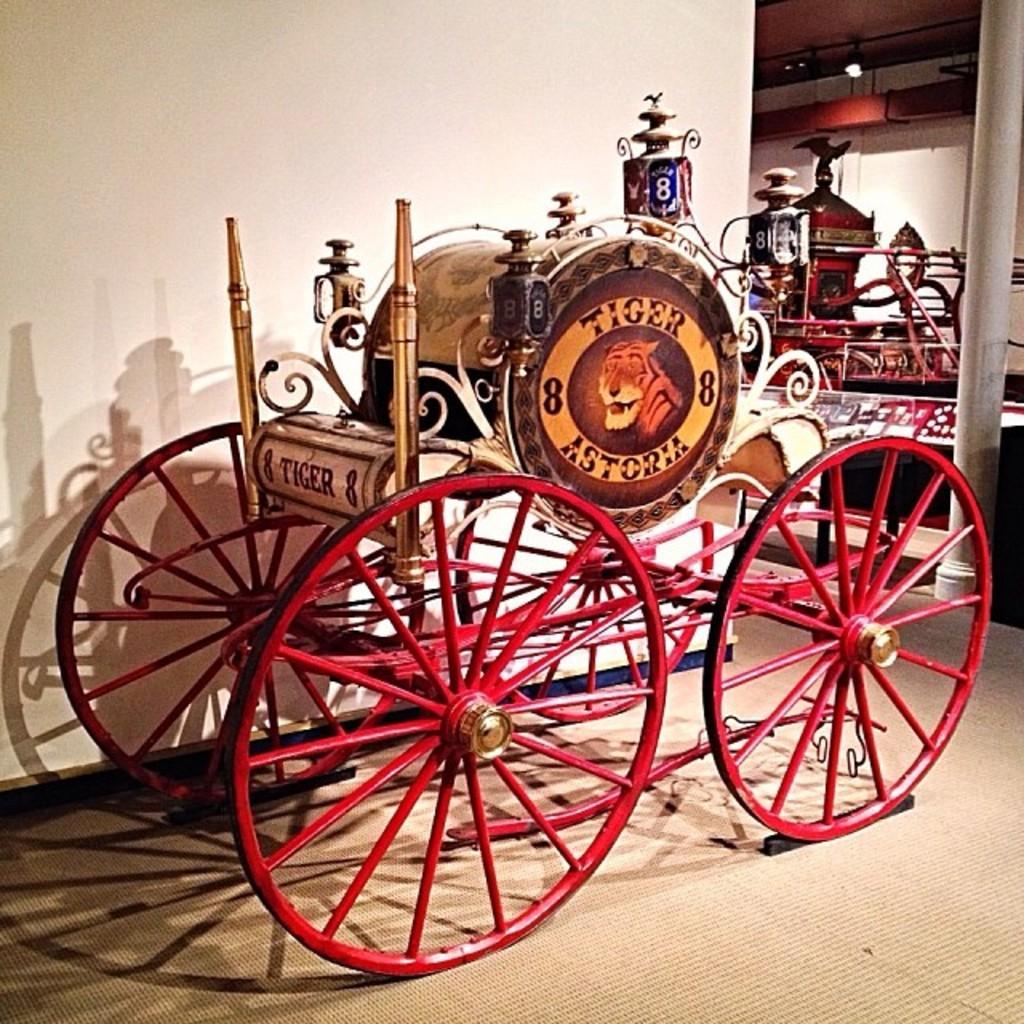Can you describe this image briefly? In this image I see a wagon which is of red in color and I see a picture of tiger over here and I see the words and numbers on this thing and I see the floor. In the background I see the wall and I can also see another wagon over here and I see the light over here. 